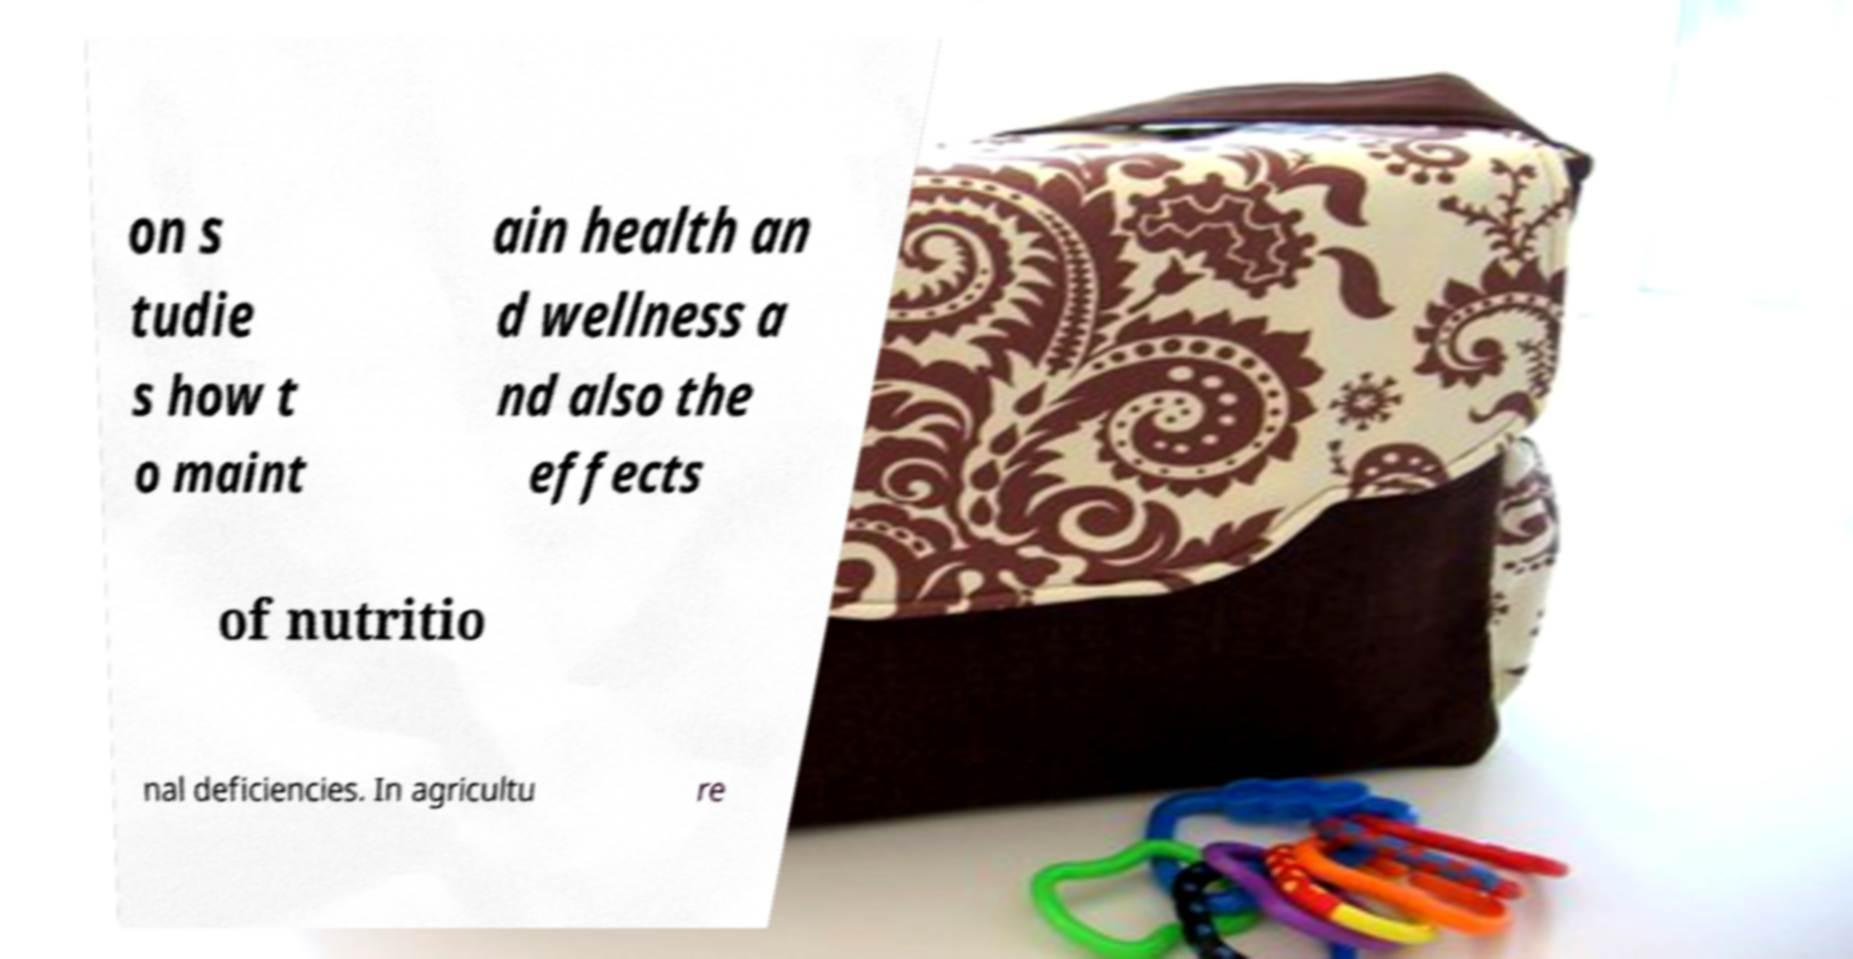Please read and relay the text visible in this image. What does it say? on s tudie s how t o maint ain health an d wellness a nd also the effects of nutritio nal deficiencies. In agricultu re 